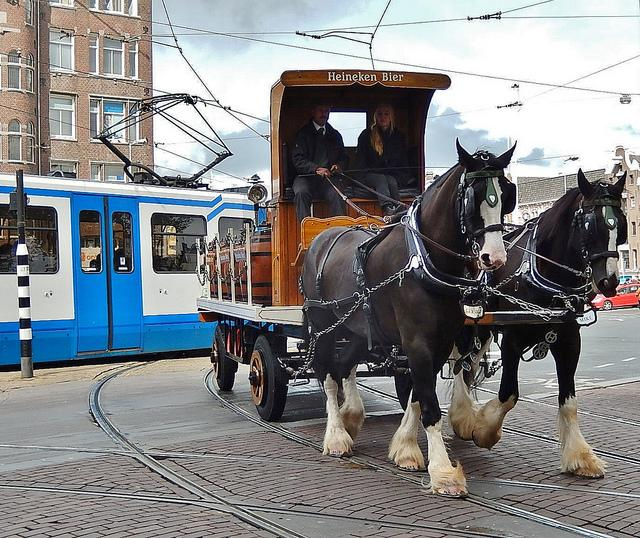What sort of product do ad men use these type horses to market?

Choices:
A) horse food
B) beer
C) pizza
D) muffins beer 